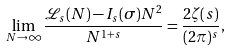Convert formula to latex. <formula><loc_0><loc_0><loc_500><loc_500>\lim _ { N \rightarrow \infty } \frac { \mathcal { L } _ { s } ( N ) - I _ { s } ( \sigma ) N ^ { 2 } } { N ^ { 1 + s } } = \frac { 2 \zeta ( s ) } { ( 2 \pi ) ^ { s } } ,</formula> 